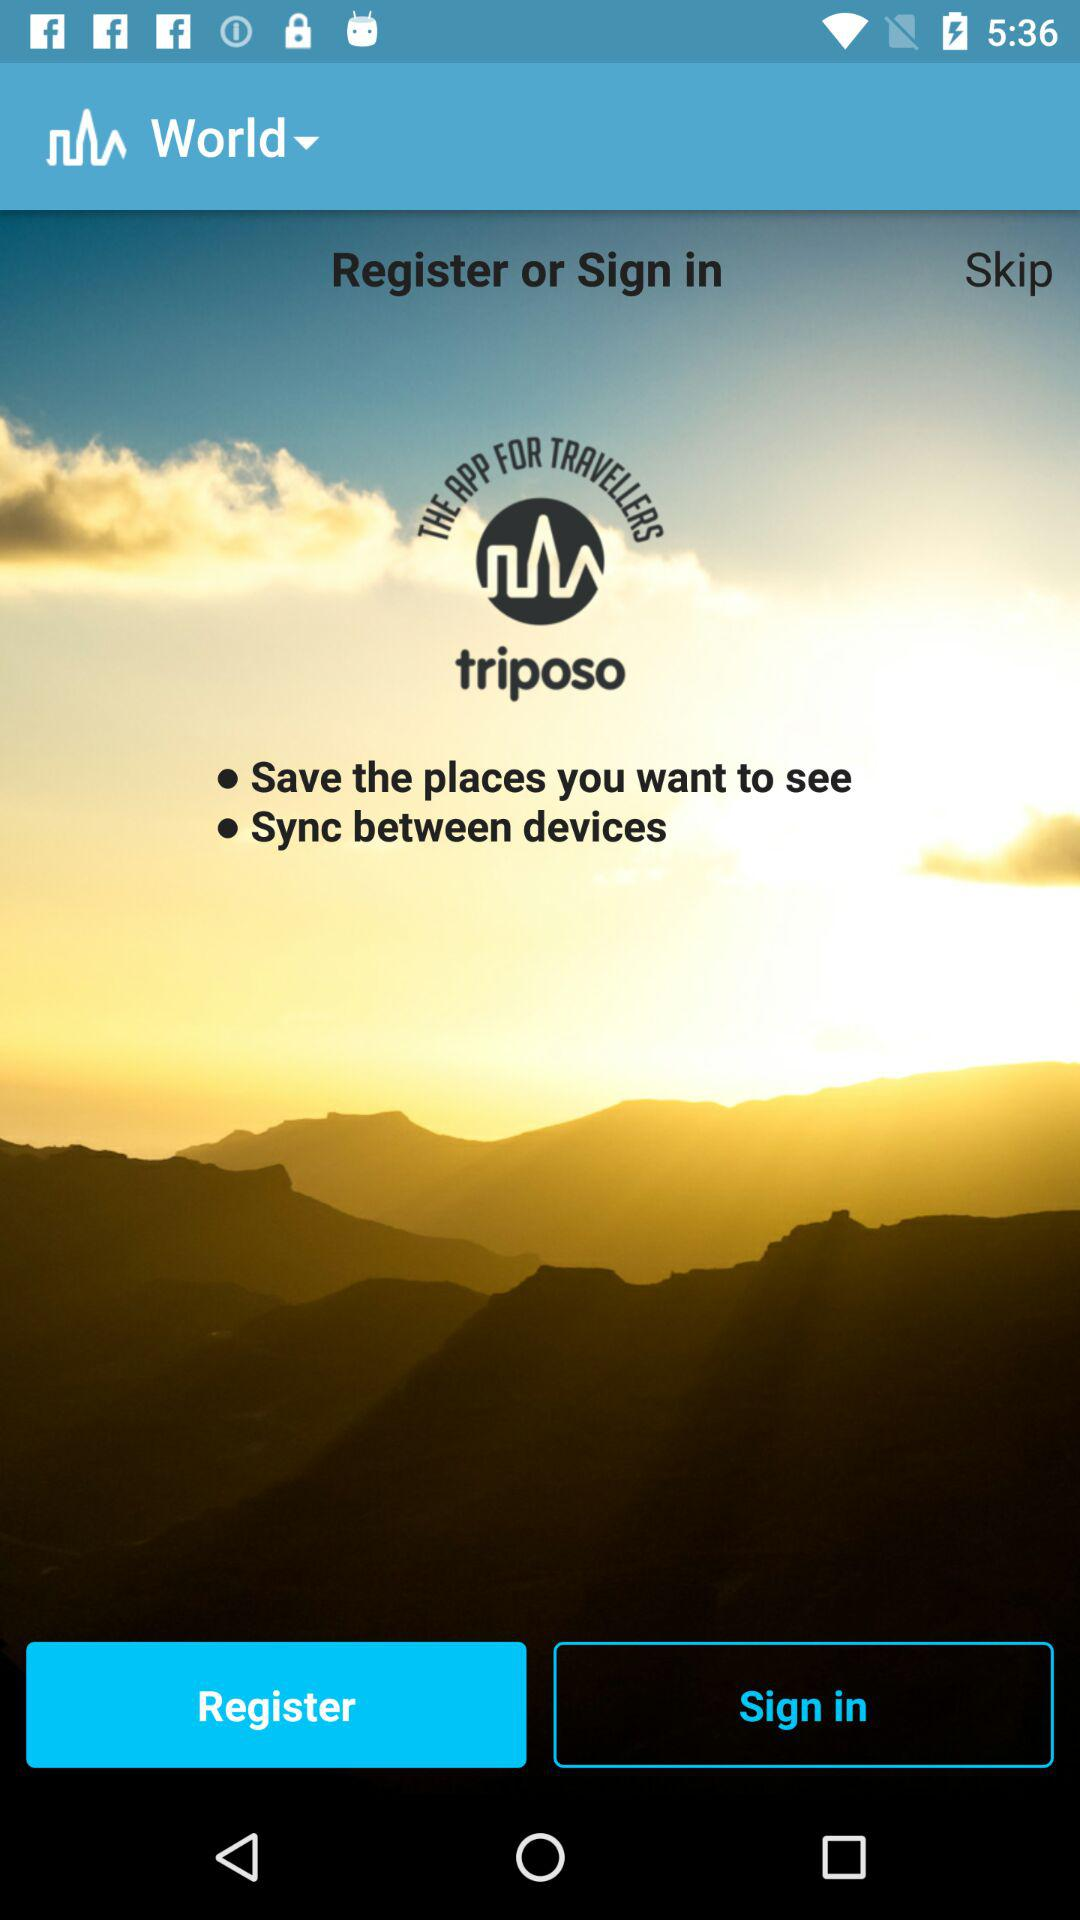How many dots are there in the Save the places you want to see Sync between devices text?
Answer the question using a single word or phrase. 2 